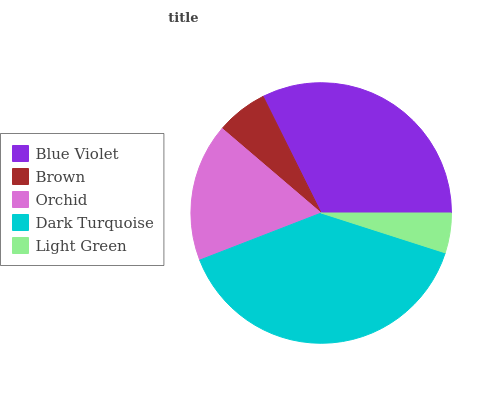Is Light Green the minimum?
Answer yes or no. Yes. Is Dark Turquoise the maximum?
Answer yes or no. Yes. Is Brown the minimum?
Answer yes or no. No. Is Brown the maximum?
Answer yes or no. No. Is Blue Violet greater than Brown?
Answer yes or no. Yes. Is Brown less than Blue Violet?
Answer yes or no. Yes. Is Brown greater than Blue Violet?
Answer yes or no. No. Is Blue Violet less than Brown?
Answer yes or no. No. Is Orchid the high median?
Answer yes or no. Yes. Is Orchid the low median?
Answer yes or no. Yes. Is Light Green the high median?
Answer yes or no. No. Is Blue Violet the low median?
Answer yes or no. No. 